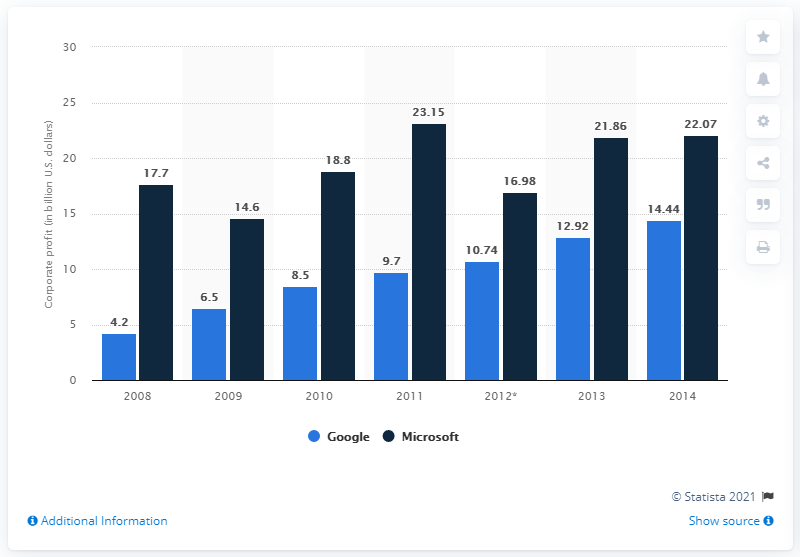Identify some key points in this picture. Google earned 14.44 million dollars in 2014. In 2008, the difference in income between good and Microsoft was at its highest. Google's net income in 2010 was $8.5 billion. 